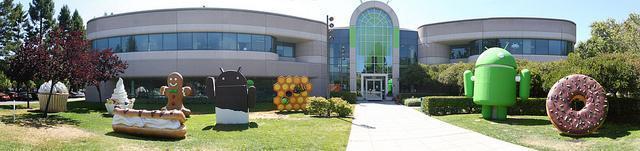What company's mascot can be seen on the right next to the donut?
Pick the correct solution from the four options below to address the question.
Options: Sony, android, apple, disney. Android. 